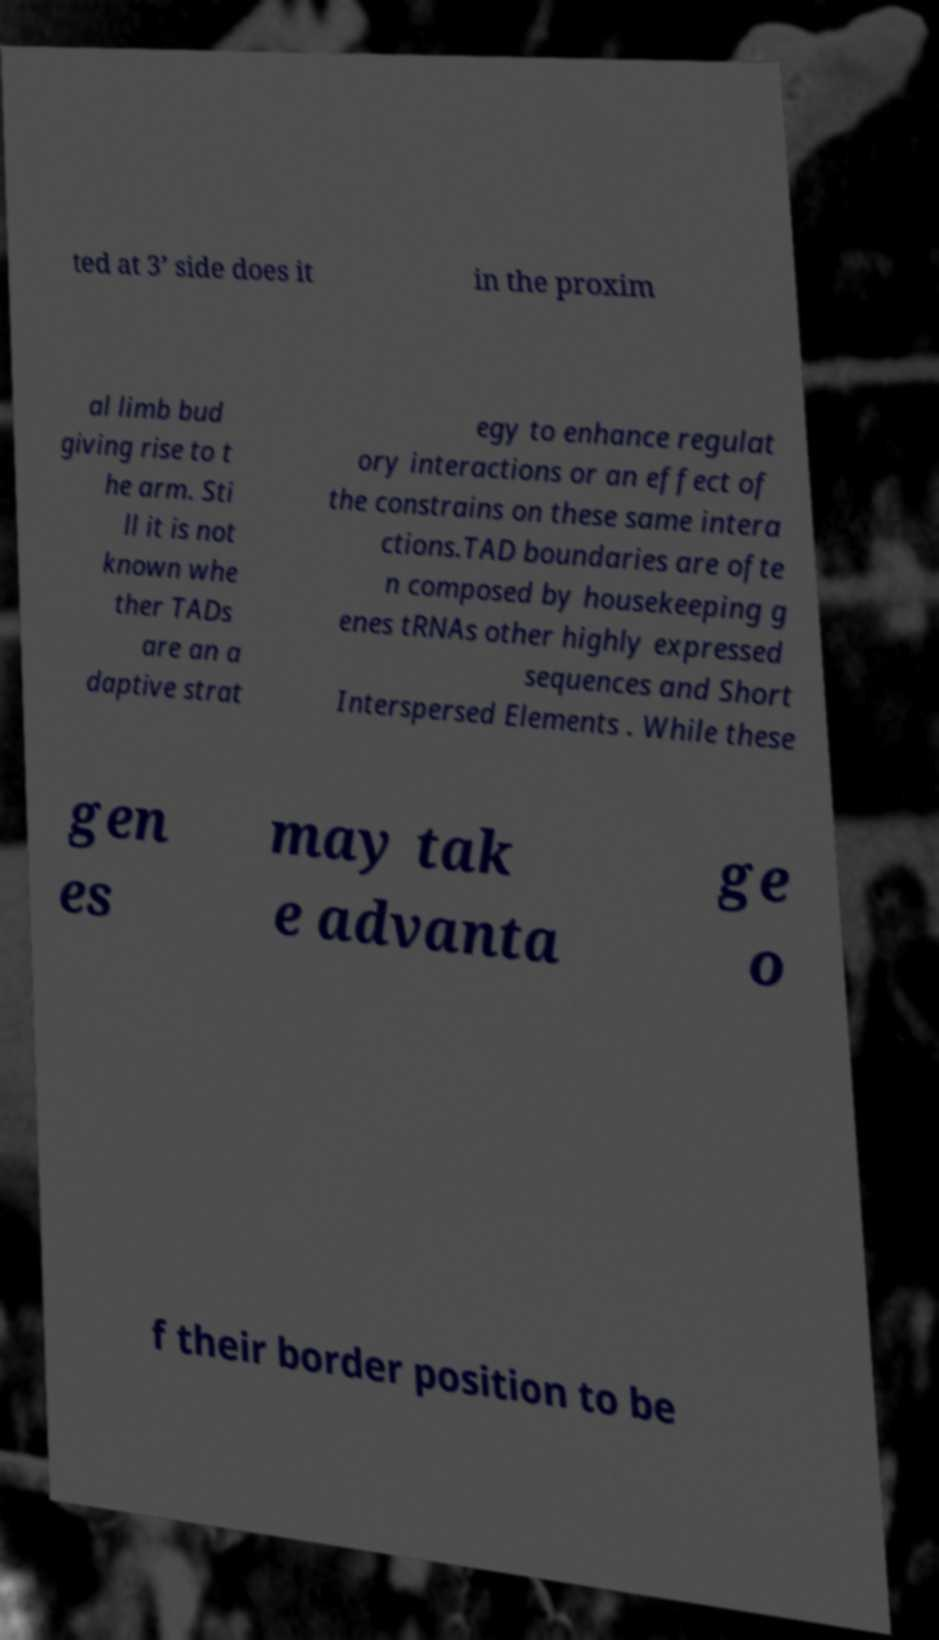Could you extract and type out the text from this image? ted at 3’ side does it in the proxim al limb bud giving rise to t he arm. Sti ll it is not known whe ther TADs are an a daptive strat egy to enhance regulat ory interactions or an effect of the constrains on these same intera ctions.TAD boundaries are ofte n composed by housekeeping g enes tRNAs other highly expressed sequences and Short Interspersed Elements . While these gen es may tak e advanta ge o f their border position to be 